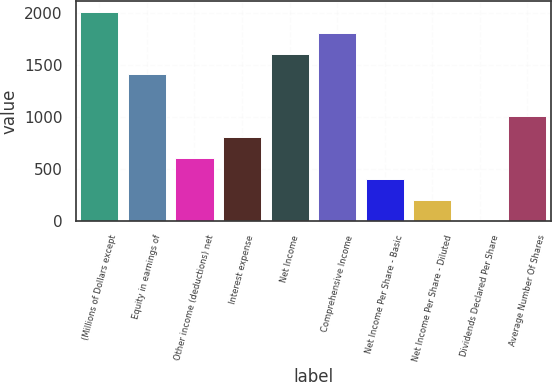Convert chart to OTSL. <chart><loc_0><loc_0><loc_500><loc_500><bar_chart><fcel>(Millions of Dollars except<fcel>Equity in earnings of<fcel>Other income (deductions) net<fcel>Interest expense<fcel>Net Income<fcel>Comprehensive Income<fcel>Net Income Per Share - Basic<fcel>Net Income Per Share - Diluted<fcel>Dividends Declared Per Share<fcel>Average Number Of Shares<nl><fcel>2013<fcel>1409.81<fcel>605.61<fcel>806.66<fcel>1610.86<fcel>1811.91<fcel>404.56<fcel>203.51<fcel>2.46<fcel>1007.71<nl></chart> 